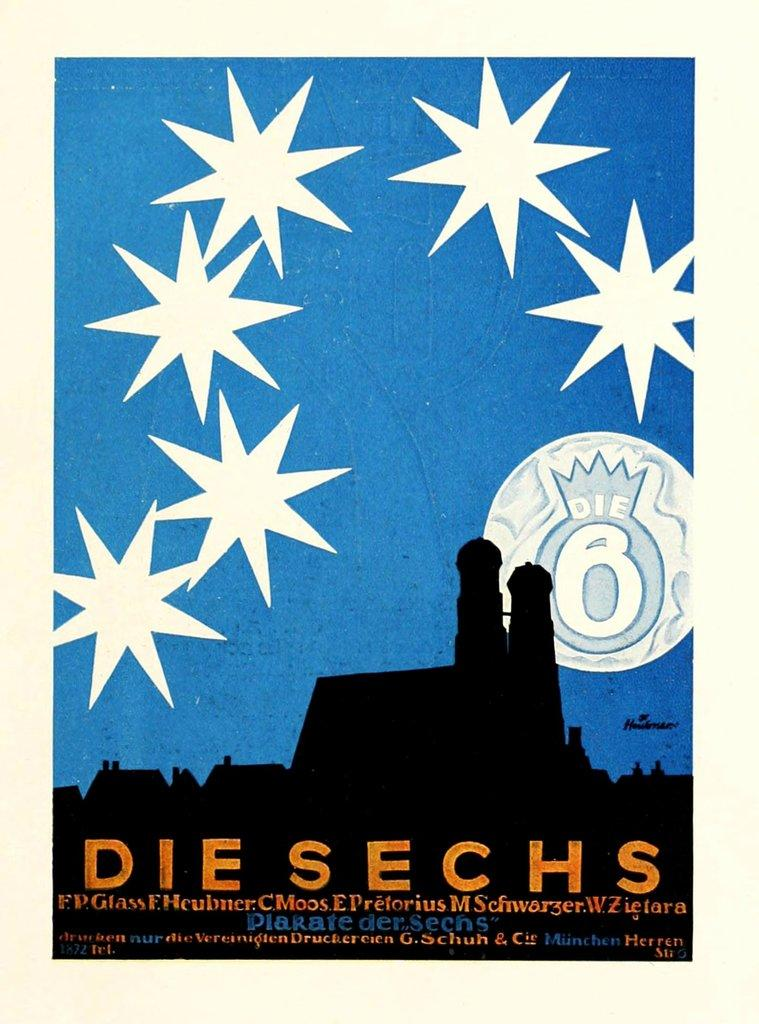<image>
Give a short and clear explanation of the subsequent image. A cover of the book titled Die Sechs with a black and blue background with six stars toward the top. 